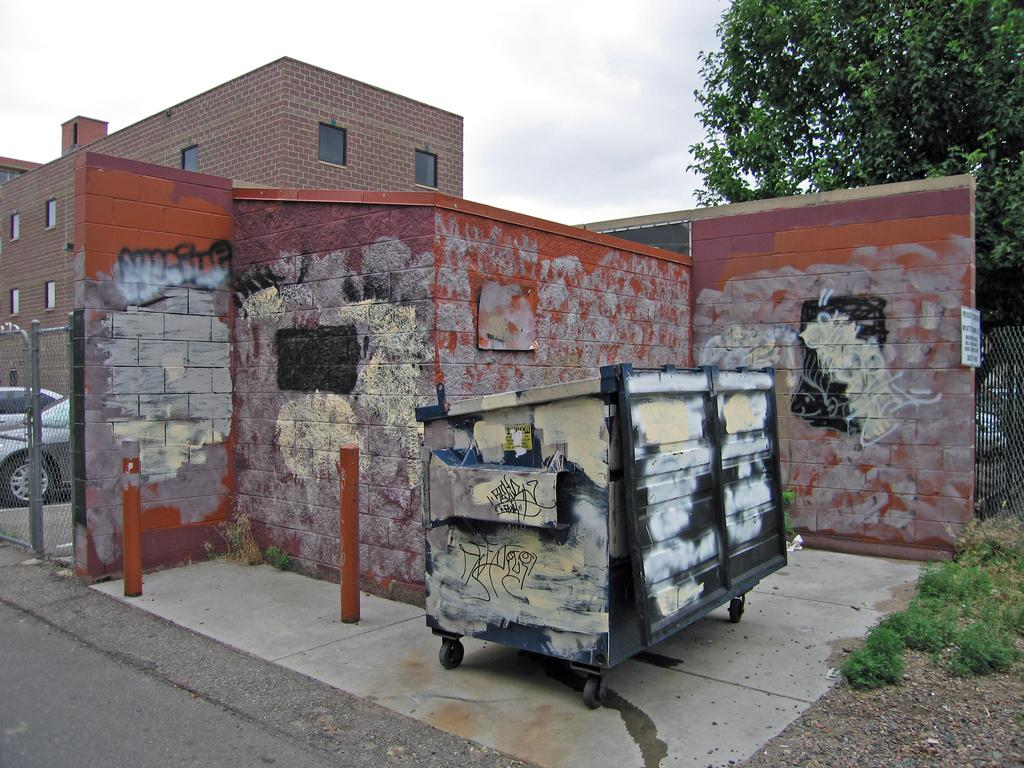What is the main object in the image? There is a cart in the image. What else can be seen in the image besides the cart? There are vehicles and traffic poles visible in the image. What can be seen in the background of the image? There are buildings, trees, and the sky visible in the background of the image. What type of sign can be seen on the dock in the image? There is no dock or sign present in the image. What shape is the ice cream in the image? There is no ice cream present in the image. 